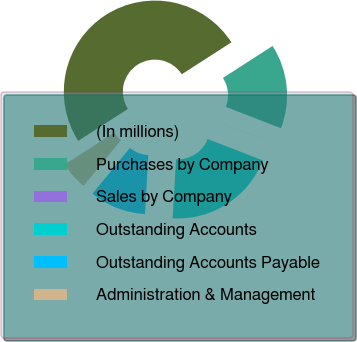Convert chart to OTSL. <chart><loc_0><loc_0><loc_500><loc_500><pie_chart><fcel>(In millions)<fcel>Purchases by Company<fcel>Sales by Company<fcel>Outstanding Accounts<fcel>Outstanding Accounts Payable<fcel>Administration & Management<nl><fcel>49.98%<fcel>15.0%<fcel>0.01%<fcel>20.0%<fcel>10.0%<fcel>5.01%<nl></chart> 